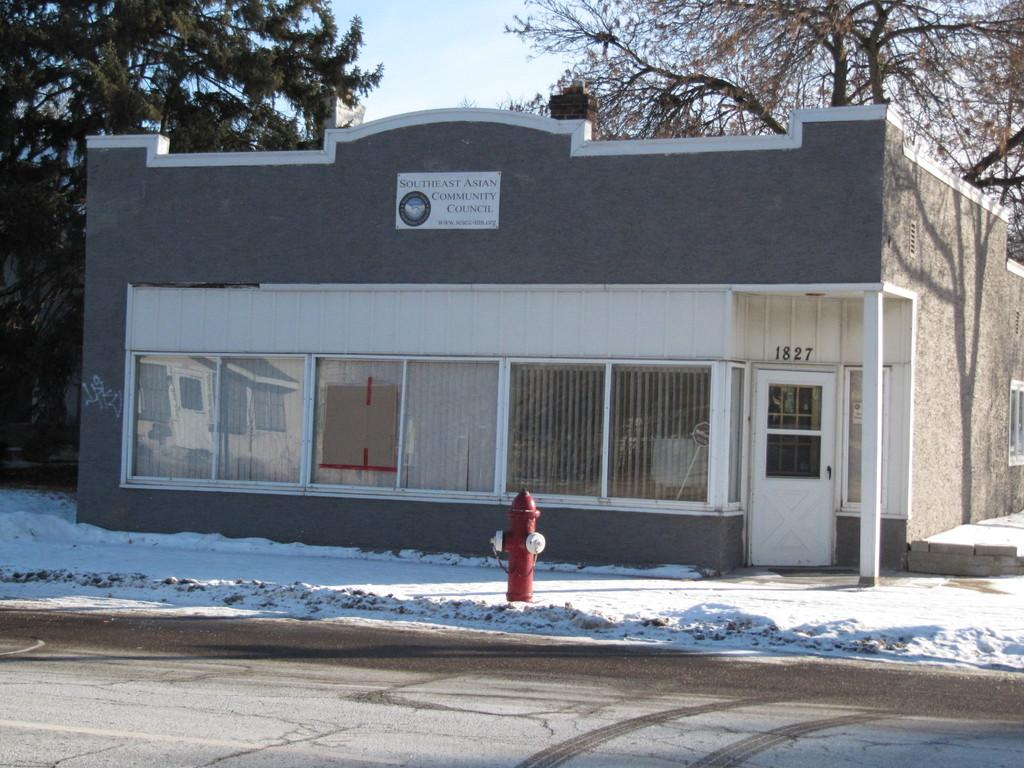What type of house is shown in the image? There is a small house with glass windows in the image. What is the weather like in the image? There is snow visible in front of the house, indicating a cold and likely wintery scene. What can be seen on the ground in front of the house? There is a red color fire hydrant on the ground in front of the house. What is visible in the background of the image? There are trees in the background of the image. Where is the market located in the image? There is no market present in the image. Is there a veil covering the windows of the house in the image? No, the windows of the house are made of glass, not covered by a veil. 